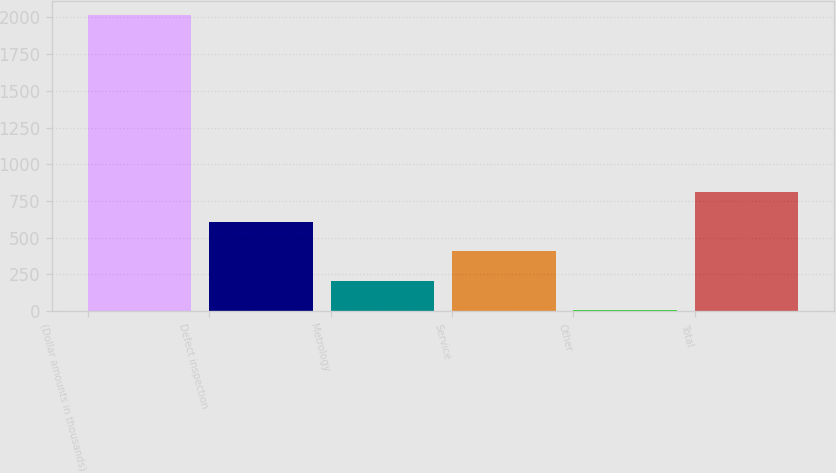Convert chart to OTSL. <chart><loc_0><loc_0><loc_500><loc_500><bar_chart><fcel>(Dollar amounts in thousands)<fcel>Defect inspection<fcel>Metrology<fcel>Service<fcel>Other<fcel>Total<nl><fcel>2015<fcel>606.6<fcel>204.2<fcel>405.4<fcel>3<fcel>807.8<nl></chart> 